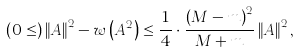<formula> <loc_0><loc_0><loc_500><loc_500>\left ( 0 \leq \right ) \left \| A \right \| ^ { 2 } - w \left ( A ^ { 2 } \right ) \leq \frac { 1 } { 4 } \cdot \frac { \left ( M - m \right ) ^ { 2 } } { M + m } \left \| A \right \| ^ { 2 } ,</formula> 